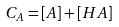Convert formula to latex. <formula><loc_0><loc_0><loc_500><loc_500>C _ { A } = [ A ] + [ H A ]</formula> 